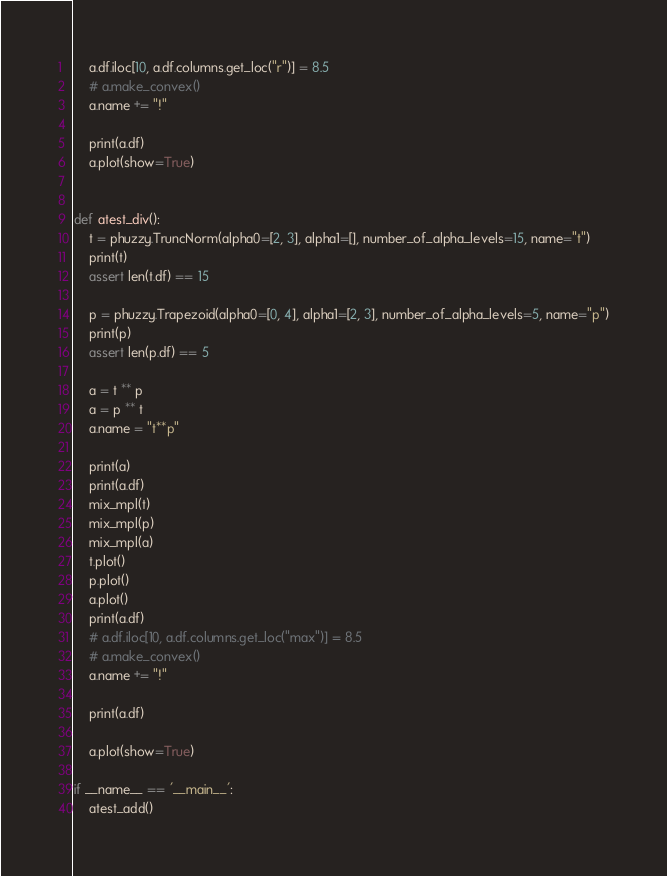Convert code to text. <code><loc_0><loc_0><loc_500><loc_500><_Python_>    a.df.iloc[10, a.df.columns.get_loc("r")] = 8.5
    # a.make_convex()
    a.name += "!"

    print(a.df)
    a.plot(show=True)


def atest_div():
    t = phuzzy.TruncNorm(alpha0=[2, 3], alpha1=[], number_of_alpha_levels=15, name="t")
    print(t)
    assert len(t.df) == 15

    p = phuzzy.Trapezoid(alpha0=[0, 4], alpha1=[2, 3], number_of_alpha_levels=5, name="p")
    print(p)
    assert len(p.df) == 5

    a = t ** p
    a = p ** t
    a.name = "t**p"

    print(a)
    print(a.df)
    mix_mpl(t)
    mix_mpl(p)
    mix_mpl(a)
    t.plot()
    p.plot()
    a.plot()
    print(a.df)
    # a.df.iloc[10, a.df.columns.get_loc("max")] = 8.5
    # a.make_convex()
    a.name += "!"

    print(a.df)

    a.plot(show=True)

if __name__ == '__main__':
    atest_add()
</code> 